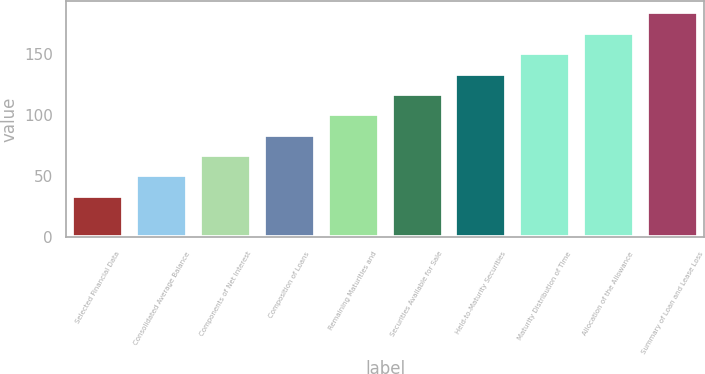Convert chart to OTSL. <chart><loc_0><loc_0><loc_500><loc_500><bar_chart><fcel>Selected Financial Data<fcel>Consolidated Average Balance<fcel>Components of Net Interest<fcel>Composition of Loans<fcel>Remaining Maturities and<fcel>Securities Available for Sale<fcel>Held-to-Maturity Securities<fcel>Maturity Distribution of Time<fcel>Allocation of the Allowance<fcel>Summary of Loan and Lease Loss<nl><fcel>34<fcel>50.7<fcel>67.4<fcel>84.1<fcel>100.8<fcel>117.5<fcel>134.2<fcel>150.9<fcel>167.6<fcel>184.3<nl></chart> 